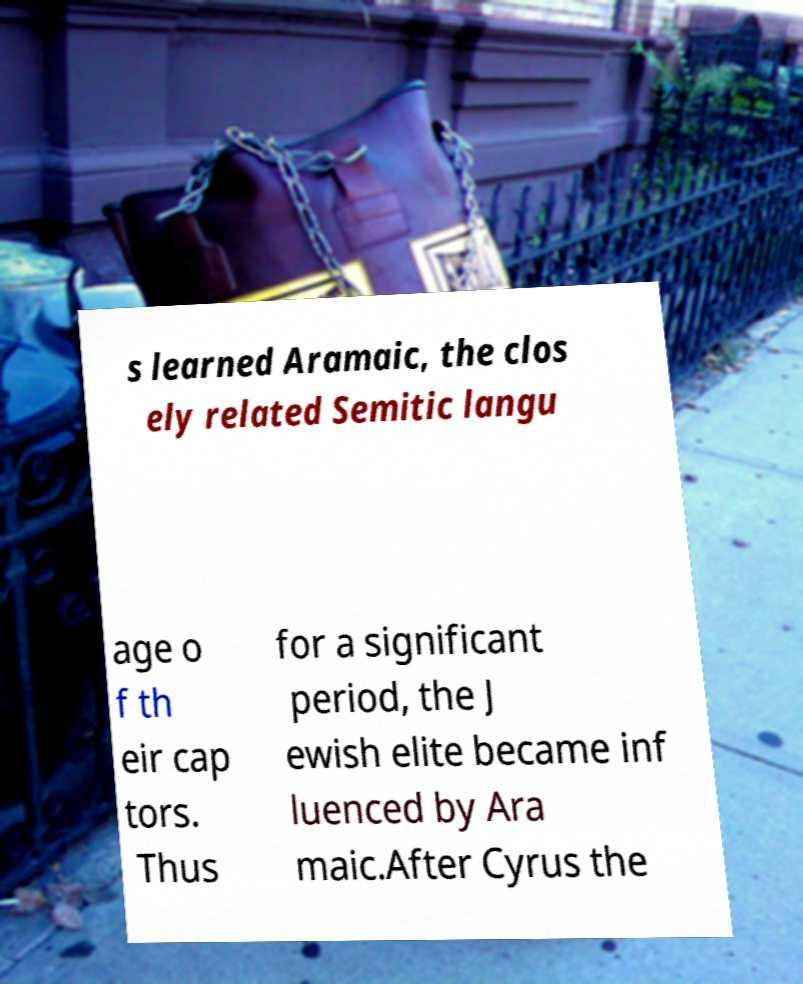Can you read and provide the text displayed in the image?This photo seems to have some interesting text. Can you extract and type it out for me? s learned Aramaic, the clos ely related Semitic langu age o f th eir cap tors. Thus for a significant period, the J ewish elite became inf luenced by Ara maic.After Cyrus the 